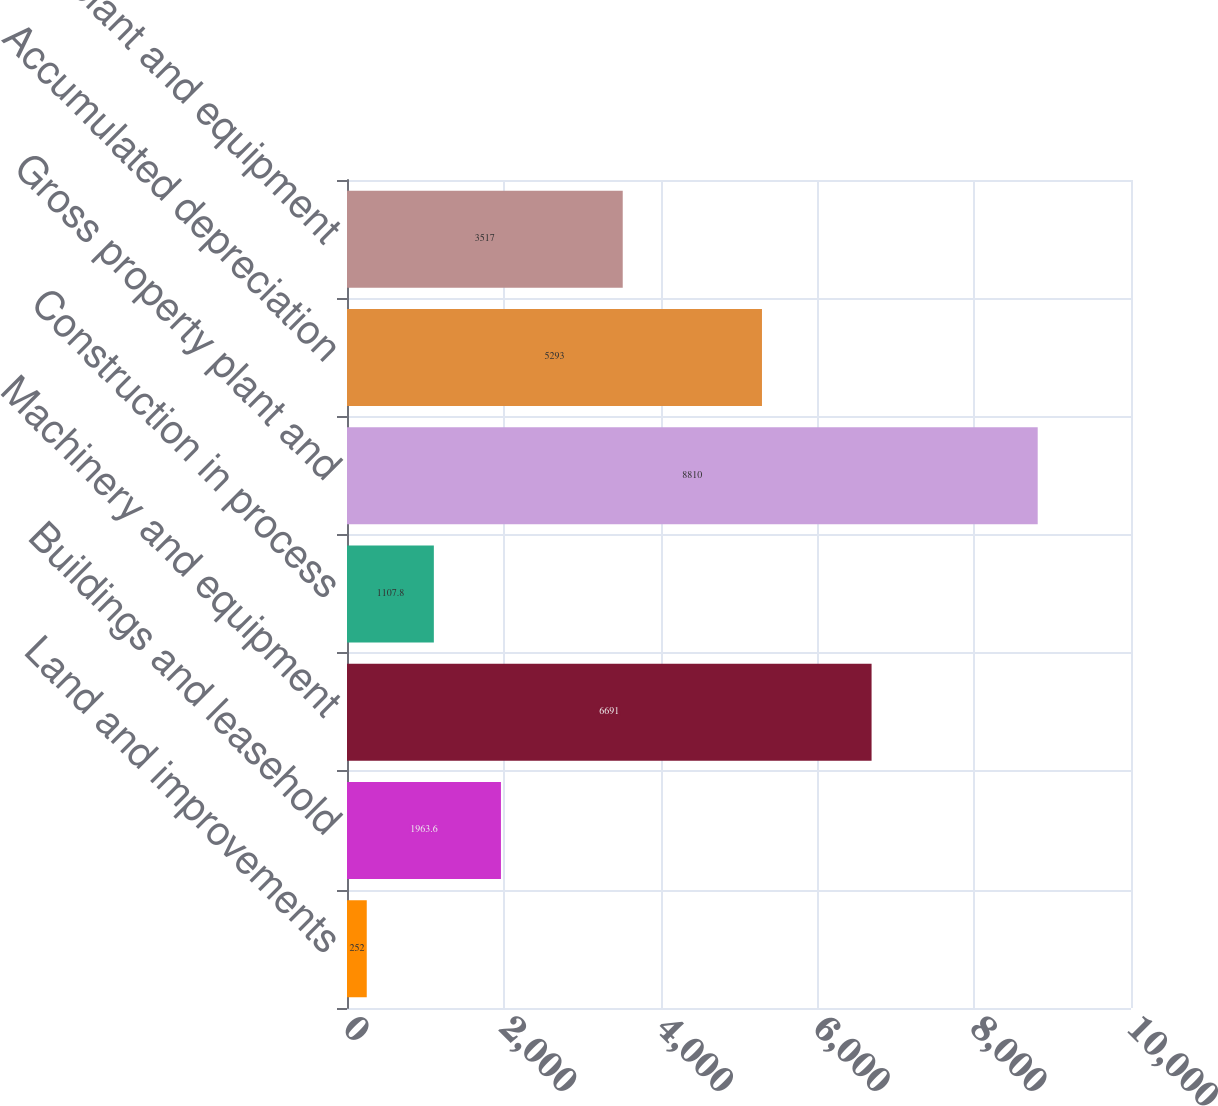Convert chart. <chart><loc_0><loc_0><loc_500><loc_500><bar_chart><fcel>Land and improvements<fcel>Buildings and leasehold<fcel>Machinery and equipment<fcel>Construction in process<fcel>Gross property plant and<fcel>Accumulated depreciation<fcel>Property plant and equipment<nl><fcel>252<fcel>1963.6<fcel>6691<fcel>1107.8<fcel>8810<fcel>5293<fcel>3517<nl></chart> 